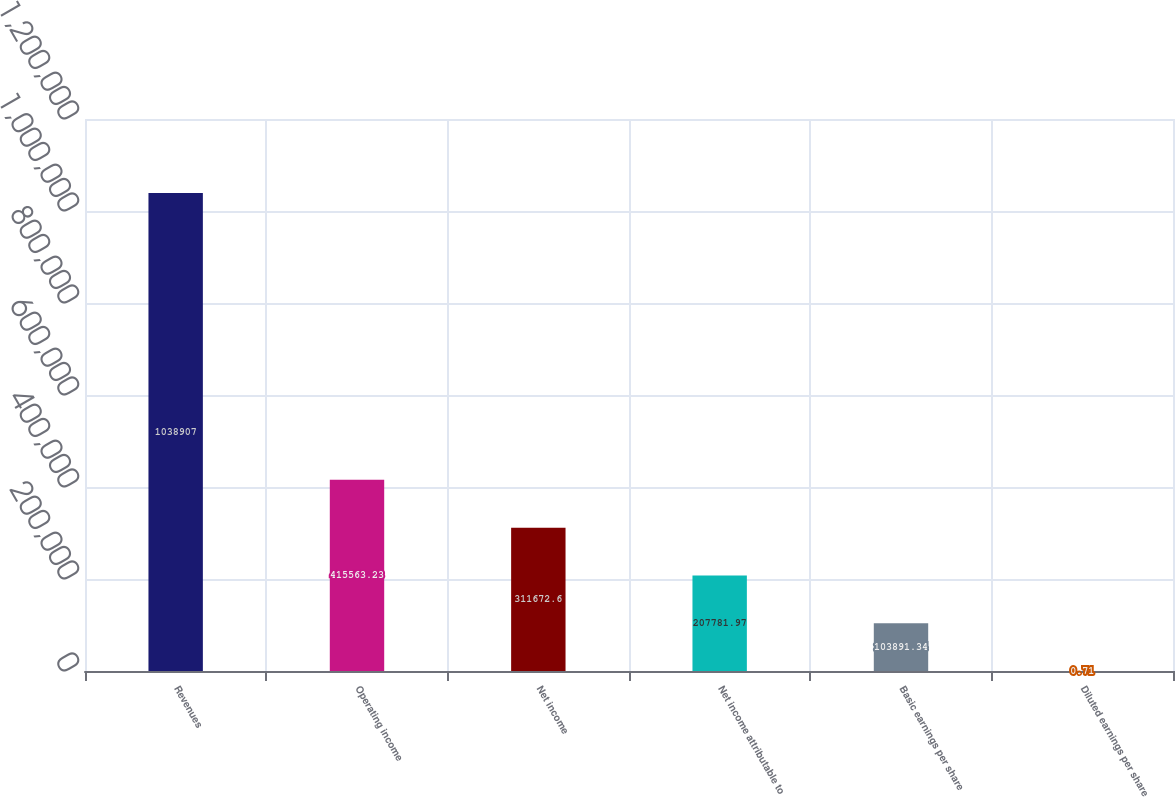Convert chart to OTSL. <chart><loc_0><loc_0><loc_500><loc_500><bar_chart><fcel>Revenues<fcel>Operating income<fcel>Net income<fcel>Net income attributable to<fcel>Basic earnings per share<fcel>Diluted earnings per share<nl><fcel>1.03891e+06<fcel>415563<fcel>311673<fcel>207782<fcel>103891<fcel>0.71<nl></chart> 